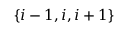Convert formula to latex. <formula><loc_0><loc_0><loc_500><loc_500>\{ i - 1 , i , i + 1 \}</formula> 